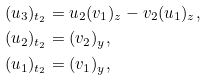Convert formula to latex. <formula><loc_0><loc_0><loc_500><loc_500>( u _ { 3 } ) _ { t _ { 2 } } & = u _ { 2 } ( v _ { 1 } ) _ { z } - v _ { 2 } ( u _ { 1 } ) _ { z } , \\ ( u _ { 2 } ) _ { t _ { 2 } } & = ( v _ { 2 } ) _ { y } , \\ ( u _ { 1 } ) _ { t _ { 2 } } & = ( v _ { 1 } ) _ { y } ,</formula> 